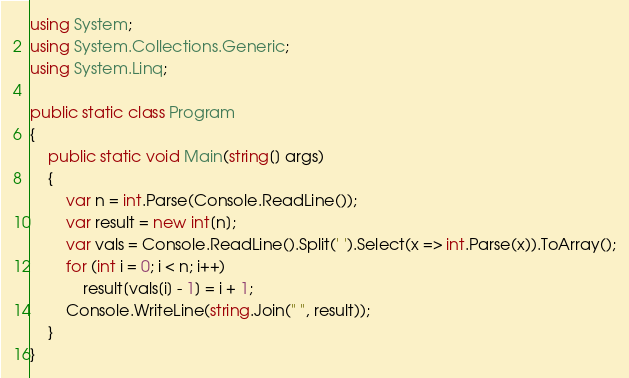Convert code to text. <code><loc_0><loc_0><loc_500><loc_500><_C#_>using System;
using System.Collections.Generic;
using System.Linq;

public static class Program
{
    public static void Main(string[] args)
    {
        var n = int.Parse(Console.ReadLine());
        var result = new int[n];
        var vals = Console.ReadLine().Split(' ').Select(x => int.Parse(x)).ToArray();
        for (int i = 0; i < n; i++)
            result[vals[i] - 1] = i + 1;
        Console.WriteLine(string.Join(" ", result));
    }
}</code> 